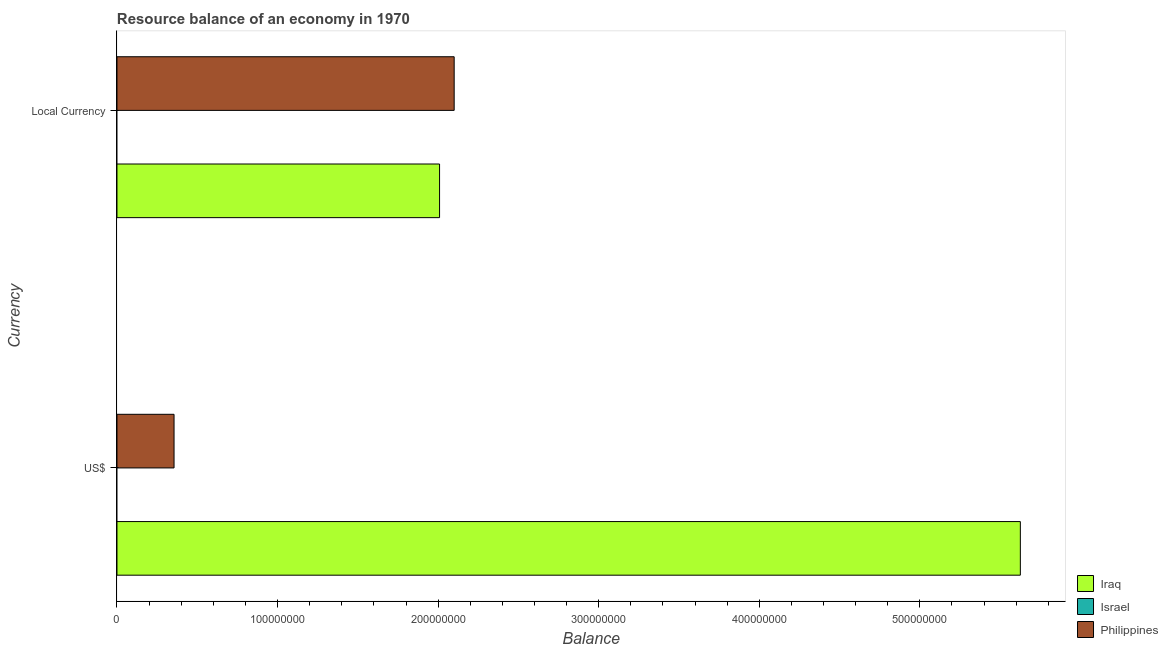How many different coloured bars are there?
Ensure brevity in your answer.  2. How many groups of bars are there?
Offer a terse response. 2. What is the label of the 2nd group of bars from the top?
Provide a succinct answer. US$. What is the resource balance in constant us$ in Philippines?
Offer a terse response. 2.10e+08. Across all countries, what is the maximum resource balance in constant us$?
Provide a succinct answer. 2.10e+08. Across all countries, what is the minimum resource balance in us$?
Your response must be concise. 0. What is the total resource balance in us$ in the graph?
Your response must be concise. 5.98e+08. What is the difference between the resource balance in constant us$ in Philippines and that in Iraq?
Your answer should be compact. 9.10e+06. What is the difference between the resource balance in us$ in Israel and the resource balance in constant us$ in Iraq?
Make the answer very short. -2.01e+08. What is the average resource balance in constant us$ per country?
Keep it short and to the point. 1.37e+08. What is the difference between the resource balance in us$ and resource balance in constant us$ in Iraq?
Offer a very short reply. 3.62e+08. What is the ratio of the resource balance in us$ in Philippines to that in Iraq?
Ensure brevity in your answer.  0.06. Is the resource balance in us$ in Iraq less than that in Philippines?
Offer a very short reply. No. How many countries are there in the graph?
Provide a succinct answer. 3. Are the values on the major ticks of X-axis written in scientific E-notation?
Offer a terse response. No. Where does the legend appear in the graph?
Provide a succinct answer. Bottom right. What is the title of the graph?
Make the answer very short. Resource balance of an economy in 1970. Does "Gambia, The" appear as one of the legend labels in the graph?
Keep it short and to the point. No. What is the label or title of the X-axis?
Your answer should be compact. Balance. What is the label or title of the Y-axis?
Keep it short and to the point. Currency. What is the Balance of Iraq in US$?
Make the answer very short. 5.63e+08. What is the Balance of Israel in US$?
Give a very brief answer. 0. What is the Balance of Philippines in US$?
Give a very brief answer. 3.55e+07. What is the Balance in Iraq in Local Currency?
Ensure brevity in your answer.  2.01e+08. What is the Balance of Philippines in Local Currency?
Your response must be concise. 2.10e+08. Across all Currency, what is the maximum Balance in Iraq?
Your answer should be very brief. 5.63e+08. Across all Currency, what is the maximum Balance of Philippines?
Provide a short and direct response. 2.10e+08. Across all Currency, what is the minimum Balance in Iraq?
Your answer should be compact. 2.01e+08. Across all Currency, what is the minimum Balance of Philippines?
Your answer should be very brief. 3.55e+07. What is the total Balance in Iraq in the graph?
Your response must be concise. 7.63e+08. What is the total Balance of Philippines in the graph?
Your answer should be compact. 2.46e+08. What is the difference between the Balance in Iraq in US$ and that in Local Currency?
Give a very brief answer. 3.62e+08. What is the difference between the Balance of Philippines in US$ and that in Local Currency?
Provide a short and direct response. -1.74e+08. What is the difference between the Balance of Iraq in US$ and the Balance of Philippines in Local Currency?
Offer a terse response. 3.53e+08. What is the average Balance in Iraq per Currency?
Keep it short and to the point. 3.82e+08. What is the average Balance in Israel per Currency?
Offer a very short reply. 0. What is the average Balance of Philippines per Currency?
Keep it short and to the point. 1.23e+08. What is the difference between the Balance of Iraq and Balance of Philippines in US$?
Keep it short and to the point. 5.27e+08. What is the difference between the Balance of Iraq and Balance of Philippines in Local Currency?
Your answer should be very brief. -9.10e+06. What is the ratio of the Balance of Iraq in US$ to that in Local Currency?
Ensure brevity in your answer.  2.8. What is the ratio of the Balance in Philippines in US$ to that in Local Currency?
Provide a succinct answer. 0.17. What is the difference between the highest and the second highest Balance of Iraq?
Ensure brevity in your answer.  3.62e+08. What is the difference between the highest and the second highest Balance of Philippines?
Offer a very short reply. 1.74e+08. What is the difference between the highest and the lowest Balance in Iraq?
Keep it short and to the point. 3.62e+08. What is the difference between the highest and the lowest Balance in Philippines?
Keep it short and to the point. 1.74e+08. 